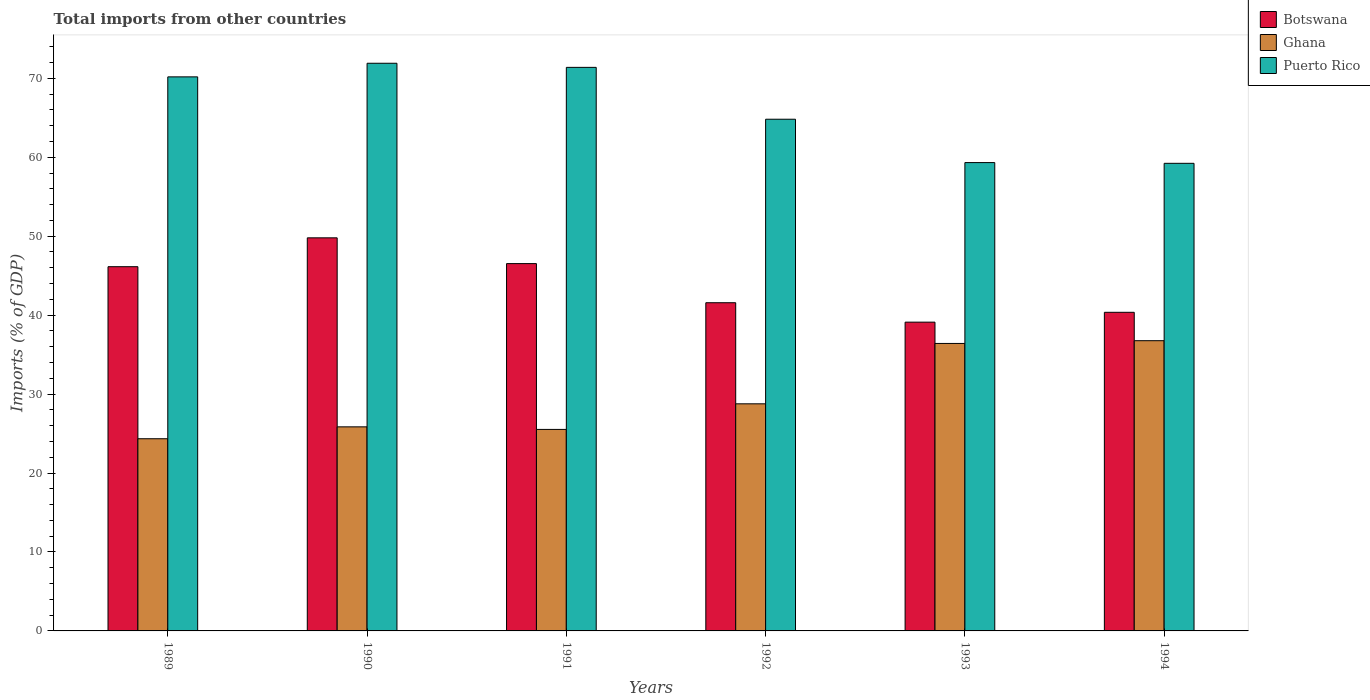How many different coloured bars are there?
Your response must be concise. 3. Are the number of bars on each tick of the X-axis equal?
Provide a succinct answer. Yes. How many bars are there on the 4th tick from the left?
Keep it short and to the point. 3. How many bars are there on the 5th tick from the right?
Your answer should be compact. 3. What is the label of the 5th group of bars from the left?
Give a very brief answer. 1993. In how many cases, is the number of bars for a given year not equal to the number of legend labels?
Keep it short and to the point. 0. What is the total imports in Ghana in 1989?
Keep it short and to the point. 24.34. Across all years, what is the maximum total imports in Ghana?
Offer a very short reply. 36.76. Across all years, what is the minimum total imports in Ghana?
Keep it short and to the point. 24.34. In which year was the total imports in Puerto Rico minimum?
Your answer should be very brief. 1994. What is the total total imports in Botswana in the graph?
Keep it short and to the point. 263.5. What is the difference between the total imports in Botswana in 1992 and that in 1994?
Offer a very short reply. 1.21. What is the difference between the total imports in Puerto Rico in 1989 and the total imports in Ghana in 1994?
Provide a succinct answer. 33.42. What is the average total imports in Puerto Rico per year?
Your answer should be very brief. 66.14. In the year 1992, what is the difference between the total imports in Ghana and total imports in Puerto Rico?
Offer a very short reply. -36.05. What is the ratio of the total imports in Ghana in 1991 to that in 1993?
Your answer should be very brief. 0.7. Is the difference between the total imports in Ghana in 1990 and 1992 greater than the difference between the total imports in Puerto Rico in 1990 and 1992?
Offer a very short reply. No. What is the difference between the highest and the second highest total imports in Botswana?
Give a very brief answer. 3.26. What is the difference between the highest and the lowest total imports in Botswana?
Make the answer very short. 10.68. What does the 3rd bar from the right in 1989 represents?
Offer a very short reply. Botswana. How many bars are there?
Provide a succinct answer. 18. Are all the bars in the graph horizontal?
Ensure brevity in your answer.  No. How many years are there in the graph?
Offer a very short reply. 6. What is the difference between two consecutive major ticks on the Y-axis?
Your answer should be compact. 10. Are the values on the major ticks of Y-axis written in scientific E-notation?
Ensure brevity in your answer.  No. How many legend labels are there?
Offer a terse response. 3. How are the legend labels stacked?
Make the answer very short. Vertical. What is the title of the graph?
Your answer should be compact. Total imports from other countries. Does "Honduras" appear as one of the legend labels in the graph?
Provide a succinct answer. No. What is the label or title of the X-axis?
Make the answer very short. Years. What is the label or title of the Y-axis?
Give a very brief answer. Imports (% of GDP). What is the Imports (% of GDP) of Botswana in 1989?
Ensure brevity in your answer.  46.14. What is the Imports (% of GDP) of Ghana in 1989?
Make the answer very short. 24.34. What is the Imports (% of GDP) of Puerto Rico in 1989?
Provide a succinct answer. 70.18. What is the Imports (% of GDP) in Botswana in 1990?
Offer a terse response. 49.79. What is the Imports (% of GDP) of Ghana in 1990?
Provide a succinct answer. 25.85. What is the Imports (% of GDP) in Puerto Rico in 1990?
Your response must be concise. 71.91. What is the Imports (% of GDP) in Botswana in 1991?
Your answer should be very brief. 46.53. What is the Imports (% of GDP) of Ghana in 1991?
Give a very brief answer. 25.52. What is the Imports (% of GDP) in Puerto Rico in 1991?
Provide a short and direct response. 71.38. What is the Imports (% of GDP) in Botswana in 1992?
Offer a very short reply. 41.57. What is the Imports (% of GDP) of Ghana in 1992?
Offer a terse response. 28.77. What is the Imports (% of GDP) in Puerto Rico in 1992?
Offer a very short reply. 64.82. What is the Imports (% of GDP) in Botswana in 1993?
Give a very brief answer. 39.11. What is the Imports (% of GDP) of Ghana in 1993?
Your answer should be very brief. 36.42. What is the Imports (% of GDP) in Puerto Rico in 1993?
Offer a terse response. 59.32. What is the Imports (% of GDP) of Botswana in 1994?
Offer a very short reply. 40.36. What is the Imports (% of GDP) in Ghana in 1994?
Your answer should be very brief. 36.76. What is the Imports (% of GDP) of Puerto Rico in 1994?
Ensure brevity in your answer.  59.23. Across all years, what is the maximum Imports (% of GDP) in Botswana?
Offer a very short reply. 49.79. Across all years, what is the maximum Imports (% of GDP) of Ghana?
Keep it short and to the point. 36.76. Across all years, what is the maximum Imports (% of GDP) of Puerto Rico?
Keep it short and to the point. 71.91. Across all years, what is the minimum Imports (% of GDP) of Botswana?
Provide a succinct answer. 39.11. Across all years, what is the minimum Imports (% of GDP) in Ghana?
Provide a short and direct response. 24.34. Across all years, what is the minimum Imports (% of GDP) in Puerto Rico?
Your answer should be compact. 59.23. What is the total Imports (% of GDP) in Botswana in the graph?
Offer a terse response. 263.5. What is the total Imports (% of GDP) in Ghana in the graph?
Give a very brief answer. 177.66. What is the total Imports (% of GDP) in Puerto Rico in the graph?
Your answer should be compact. 396.84. What is the difference between the Imports (% of GDP) of Botswana in 1989 and that in 1990?
Provide a short and direct response. -3.66. What is the difference between the Imports (% of GDP) in Ghana in 1989 and that in 1990?
Offer a very short reply. -1.51. What is the difference between the Imports (% of GDP) of Puerto Rico in 1989 and that in 1990?
Provide a short and direct response. -1.72. What is the difference between the Imports (% of GDP) of Botswana in 1989 and that in 1991?
Your answer should be very brief. -0.39. What is the difference between the Imports (% of GDP) of Ghana in 1989 and that in 1991?
Offer a terse response. -1.18. What is the difference between the Imports (% of GDP) in Puerto Rico in 1989 and that in 1991?
Provide a short and direct response. -1.2. What is the difference between the Imports (% of GDP) in Botswana in 1989 and that in 1992?
Your answer should be very brief. 4.56. What is the difference between the Imports (% of GDP) in Ghana in 1989 and that in 1992?
Provide a succinct answer. -4.42. What is the difference between the Imports (% of GDP) in Puerto Rico in 1989 and that in 1992?
Give a very brief answer. 5.37. What is the difference between the Imports (% of GDP) of Botswana in 1989 and that in 1993?
Give a very brief answer. 7.02. What is the difference between the Imports (% of GDP) of Ghana in 1989 and that in 1993?
Ensure brevity in your answer.  -12.07. What is the difference between the Imports (% of GDP) of Puerto Rico in 1989 and that in 1993?
Your answer should be compact. 10.86. What is the difference between the Imports (% of GDP) in Botswana in 1989 and that in 1994?
Offer a terse response. 5.78. What is the difference between the Imports (% of GDP) of Ghana in 1989 and that in 1994?
Your answer should be compact. -12.42. What is the difference between the Imports (% of GDP) of Puerto Rico in 1989 and that in 1994?
Keep it short and to the point. 10.95. What is the difference between the Imports (% of GDP) of Botswana in 1990 and that in 1991?
Make the answer very short. 3.26. What is the difference between the Imports (% of GDP) in Ghana in 1990 and that in 1991?
Provide a short and direct response. 0.33. What is the difference between the Imports (% of GDP) of Puerto Rico in 1990 and that in 1991?
Make the answer very short. 0.52. What is the difference between the Imports (% of GDP) in Botswana in 1990 and that in 1992?
Offer a very short reply. 8.22. What is the difference between the Imports (% of GDP) in Ghana in 1990 and that in 1992?
Your answer should be very brief. -2.92. What is the difference between the Imports (% of GDP) in Puerto Rico in 1990 and that in 1992?
Offer a terse response. 7.09. What is the difference between the Imports (% of GDP) of Botswana in 1990 and that in 1993?
Provide a short and direct response. 10.68. What is the difference between the Imports (% of GDP) of Ghana in 1990 and that in 1993?
Ensure brevity in your answer.  -10.56. What is the difference between the Imports (% of GDP) in Puerto Rico in 1990 and that in 1993?
Offer a terse response. 12.58. What is the difference between the Imports (% of GDP) of Botswana in 1990 and that in 1994?
Offer a terse response. 9.43. What is the difference between the Imports (% of GDP) of Ghana in 1990 and that in 1994?
Your answer should be compact. -10.91. What is the difference between the Imports (% of GDP) of Puerto Rico in 1990 and that in 1994?
Keep it short and to the point. 12.68. What is the difference between the Imports (% of GDP) in Botswana in 1991 and that in 1992?
Ensure brevity in your answer.  4.96. What is the difference between the Imports (% of GDP) in Ghana in 1991 and that in 1992?
Your response must be concise. -3.24. What is the difference between the Imports (% of GDP) in Puerto Rico in 1991 and that in 1992?
Provide a succinct answer. 6.57. What is the difference between the Imports (% of GDP) in Botswana in 1991 and that in 1993?
Keep it short and to the point. 7.42. What is the difference between the Imports (% of GDP) of Ghana in 1991 and that in 1993?
Provide a succinct answer. -10.89. What is the difference between the Imports (% of GDP) of Puerto Rico in 1991 and that in 1993?
Ensure brevity in your answer.  12.06. What is the difference between the Imports (% of GDP) in Botswana in 1991 and that in 1994?
Your answer should be very brief. 6.17. What is the difference between the Imports (% of GDP) of Ghana in 1991 and that in 1994?
Make the answer very short. -11.24. What is the difference between the Imports (% of GDP) of Puerto Rico in 1991 and that in 1994?
Your answer should be compact. 12.15. What is the difference between the Imports (% of GDP) in Botswana in 1992 and that in 1993?
Make the answer very short. 2.46. What is the difference between the Imports (% of GDP) of Ghana in 1992 and that in 1993?
Make the answer very short. -7.65. What is the difference between the Imports (% of GDP) in Puerto Rico in 1992 and that in 1993?
Give a very brief answer. 5.49. What is the difference between the Imports (% of GDP) of Botswana in 1992 and that in 1994?
Keep it short and to the point. 1.21. What is the difference between the Imports (% of GDP) of Ghana in 1992 and that in 1994?
Keep it short and to the point. -7.99. What is the difference between the Imports (% of GDP) in Puerto Rico in 1992 and that in 1994?
Your answer should be compact. 5.59. What is the difference between the Imports (% of GDP) in Botswana in 1993 and that in 1994?
Give a very brief answer. -1.25. What is the difference between the Imports (% of GDP) in Ghana in 1993 and that in 1994?
Ensure brevity in your answer.  -0.35. What is the difference between the Imports (% of GDP) of Puerto Rico in 1993 and that in 1994?
Give a very brief answer. 0.09. What is the difference between the Imports (% of GDP) in Botswana in 1989 and the Imports (% of GDP) in Ghana in 1990?
Offer a very short reply. 20.29. What is the difference between the Imports (% of GDP) of Botswana in 1989 and the Imports (% of GDP) of Puerto Rico in 1990?
Give a very brief answer. -25.77. What is the difference between the Imports (% of GDP) of Ghana in 1989 and the Imports (% of GDP) of Puerto Rico in 1990?
Give a very brief answer. -47.56. What is the difference between the Imports (% of GDP) of Botswana in 1989 and the Imports (% of GDP) of Ghana in 1991?
Offer a very short reply. 20.61. What is the difference between the Imports (% of GDP) in Botswana in 1989 and the Imports (% of GDP) in Puerto Rico in 1991?
Ensure brevity in your answer.  -25.25. What is the difference between the Imports (% of GDP) of Ghana in 1989 and the Imports (% of GDP) of Puerto Rico in 1991?
Offer a very short reply. -47.04. What is the difference between the Imports (% of GDP) of Botswana in 1989 and the Imports (% of GDP) of Ghana in 1992?
Ensure brevity in your answer.  17.37. What is the difference between the Imports (% of GDP) of Botswana in 1989 and the Imports (% of GDP) of Puerto Rico in 1992?
Provide a succinct answer. -18.68. What is the difference between the Imports (% of GDP) of Ghana in 1989 and the Imports (% of GDP) of Puerto Rico in 1992?
Ensure brevity in your answer.  -40.47. What is the difference between the Imports (% of GDP) of Botswana in 1989 and the Imports (% of GDP) of Ghana in 1993?
Ensure brevity in your answer.  9.72. What is the difference between the Imports (% of GDP) in Botswana in 1989 and the Imports (% of GDP) in Puerto Rico in 1993?
Provide a short and direct response. -13.19. What is the difference between the Imports (% of GDP) of Ghana in 1989 and the Imports (% of GDP) of Puerto Rico in 1993?
Your response must be concise. -34.98. What is the difference between the Imports (% of GDP) in Botswana in 1989 and the Imports (% of GDP) in Ghana in 1994?
Your answer should be very brief. 9.37. What is the difference between the Imports (% of GDP) of Botswana in 1989 and the Imports (% of GDP) of Puerto Rico in 1994?
Your answer should be compact. -13.09. What is the difference between the Imports (% of GDP) in Ghana in 1989 and the Imports (% of GDP) in Puerto Rico in 1994?
Your answer should be compact. -34.89. What is the difference between the Imports (% of GDP) in Botswana in 1990 and the Imports (% of GDP) in Ghana in 1991?
Offer a very short reply. 24.27. What is the difference between the Imports (% of GDP) of Botswana in 1990 and the Imports (% of GDP) of Puerto Rico in 1991?
Make the answer very short. -21.59. What is the difference between the Imports (% of GDP) of Ghana in 1990 and the Imports (% of GDP) of Puerto Rico in 1991?
Keep it short and to the point. -45.53. What is the difference between the Imports (% of GDP) of Botswana in 1990 and the Imports (% of GDP) of Ghana in 1992?
Provide a succinct answer. 21.02. What is the difference between the Imports (% of GDP) of Botswana in 1990 and the Imports (% of GDP) of Puerto Rico in 1992?
Keep it short and to the point. -15.02. What is the difference between the Imports (% of GDP) in Ghana in 1990 and the Imports (% of GDP) in Puerto Rico in 1992?
Offer a very short reply. -38.97. What is the difference between the Imports (% of GDP) in Botswana in 1990 and the Imports (% of GDP) in Ghana in 1993?
Offer a very short reply. 13.38. What is the difference between the Imports (% of GDP) in Botswana in 1990 and the Imports (% of GDP) in Puerto Rico in 1993?
Ensure brevity in your answer.  -9.53. What is the difference between the Imports (% of GDP) in Ghana in 1990 and the Imports (% of GDP) in Puerto Rico in 1993?
Ensure brevity in your answer.  -33.47. What is the difference between the Imports (% of GDP) in Botswana in 1990 and the Imports (% of GDP) in Ghana in 1994?
Give a very brief answer. 13.03. What is the difference between the Imports (% of GDP) of Botswana in 1990 and the Imports (% of GDP) of Puerto Rico in 1994?
Give a very brief answer. -9.44. What is the difference between the Imports (% of GDP) of Ghana in 1990 and the Imports (% of GDP) of Puerto Rico in 1994?
Your answer should be very brief. -33.38. What is the difference between the Imports (% of GDP) of Botswana in 1991 and the Imports (% of GDP) of Ghana in 1992?
Your answer should be very brief. 17.76. What is the difference between the Imports (% of GDP) of Botswana in 1991 and the Imports (% of GDP) of Puerto Rico in 1992?
Your answer should be compact. -18.29. What is the difference between the Imports (% of GDP) in Ghana in 1991 and the Imports (% of GDP) in Puerto Rico in 1992?
Offer a terse response. -39.29. What is the difference between the Imports (% of GDP) of Botswana in 1991 and the Imports (% of GDP) of Ghana in 1993?
Your answer should be compact. 10.11. What is the difference between the Imports (% of GDP) in Botswana in 1991 and the Imports (% of GDP) in Puerto Rico in 1993?
Your response must be concise. -12.8. What is the difference between the Imports (% of GDP) of Ghana in 1991 and the Imports (% of GDP) of Puerto Rico in 1993?
Provide a short and direct response. -33.8. What is the difference between the Imports (% of GDP) in Botswana in 1991 and the Imports (% of GDP) in Ghana in 1994?
Provide a short and direct response. 9.77. What is the difference between the Imports (% of GDP) in Botswana in 1991 and the Imports (% of GDP) in Puerto Rico in 1994?
Your response must be concise. -12.7. What is the difference between the Imports (% of GDP) of Ghana in 1991 and the Imports (% of GDP) of Puerto Rico in 1994?
Your answer should be very brief. -33.71. What is the difference between the Imports (% of GDP) in Botswana in 1992 and the Imports (% of GDP) in Ghana in 1993?
Your answer should be very brief. 5.16. What is the difference between the Imports (% of GDP) of Botswana in 1992 and the Imports (% of GDP) of Puerto Rico in 1993?
Provide a succinct answer. -17.75. What is the difference between the Imports (% of GDP) in Ghana in 1992 and the Imports (% of GDP) in Puerto Rico in 1993?
Make the answer very short. -30.56. What is the difference between the Imports (% of GDP) in Botswana in 1992 and the Imports (% of GDP) in Ghana in 1994?
Offer a very short reply. 4.81. What is the difference between the Imports (% of GDP) of Botswana in 1992 and the Imports (% of GDP) of Puerto Rico in 1994?
Give a very brief answer. -17.66. What is the difference between the Imports (% of GDP) of Ghana in 1992 and the Imports (% of GDP) of Puerto Rico in 1994?
Provide a succinct answer. -30.46. What is the difference between the Imports (% of GDP) of Botswana in 1993 and the Imports (% of GDP) of Ghana in 1994?
Offer a very short reply. 2.35. What is the difference between the Imports (% of GDP) in Botswana in 1993 and the Imports (% of GDP) in Puerto Rico in 1994?
Give a very brief answer. -20.12. What is the difference between the Imports (% of GDP) of Ghana in 1993 and the Imports (% of GDP) of Puerto Rico in 1994?
Give a very brief answer. -22.82. What is the average Imports (% of GDP) in Botswana per year?
Your response must be concise. 43.92. What is the average Imports (% of GDP) in Ghana per year?
Give a very brief answer. 29.61. What is the average Imports (% of GDP) in Puerto Rico per year?
Your response must be concise. 66.14. In the year 1989, what is the difference between the Imports (% of GDP) in Botswana and Imports (% of GDP) in Ghana?
Offer a terse response. 21.79. In the year 1989, what is the difference between the Imports (% of GDP) of Botswana and Imports (% of GDP) of Puerto Rico?
Your response must be concise. -24.05. In the year 1989, what is the difference between the Imports (% of GDP) of Ghana and Imports (% of GDP) of Puerto Rico?
Offer a very short reply. -45.84. In the year 1990, what is the difference between the Imports (% of GDP) in Botswana and Imports (% of GDP) in Ghana?
Ensure brevity in your answer.  23.94. In the year 1990, what is the difference between the Imports (% of GDP) of Botswana and Imports (% of GDP) of Puerto Rico?
Offer a very short reply. -22.11. In the year 1990, what is the difference between the Imports (% of GDP) in Ghana and Imports (% of GDP) in Puerto Rico?
Ensure brevity in your answer.  -46.06. In the year 1991, what is the difference between the Imports (% of GDP) in Botswana and Imports (% of GDP) in Ghana?
Your answer should be compact. 21. In the year 1991, what is the difference between the Imports (% of GDP) in Botswana and Imports (% of GDP) in Puerto Rico?
Provide a short and direct response. -24.86. In the year 1991, what is the difference between the Imports (% of GDP) of Ghana and Imports (% of GDP) of Puerto Rico?
Give a very brief answer. -45.86. In the year 1992, what is the difference between the Imports (% of GDP) in Botswana and Imports (% of GDP) in Ghana?
Make the answer very short. 12.8. In the year 1992, what is the difference between the Imports (% of GDP) of Botswana and Imports (% of GDP) of Puerto Rico?
Make the answer very short. -23.24. In the year 1992, what is the difference between the Imports (% of GDP) in Ghana and Imports (% of GDP) in Puerto Rico?
Provide a succinct answer. -36.05. In the year 1993, what is the difference between the Imports (% of GDP) in Botswana and Imports (% of GDP) in Ghana?
Make the answer very short. 2.7. In the year 1993, what is the difference between the Imports (% of GDP) in Botswana and Imports (% of GDP) in Puerto Rico?
Your answer should be compact. -20.21. In the year 1993, what is the difference between the Imports (% of GDP) in Ghana and Imports (% of GDP) in Puerto Rico?
Your answer should be very brief. -22.91. In the year 1994, what is the difference between the Imports (% of GDP) of Botswana and Imports (% of GDP) of Ghana?
Your answer should be compact. 3.6. In the year 1994, what is the difference between the Imports (% of GDP) of Botswana and Imports (% of GDP) of Puerto Rico?
Provide a short and direct response. -18.87. In the year 1994, what is the difference between the Imports (% of GDP) in Ghana and Imports (% of GDP) in Puerto Rico?
Give a very brief answer. -22.47. What is the ratio of the Imports (% of GDP) of Botswana in 1989 to that in 1990?
Offer a terse response. 0.93. What is the ratio of the Imports (% of GDP) of Ghana in 1989 to that in 1990?
Your response must be concise. 0.94. What is the ratio of the Imports (% of GDP) in Puerto Rico in 1989 to that in 1990?
Provide a short and direct response. 0.98. What is the ratio of the Imports (% of GDP) in Botswana in 1989 to that in 1991?
Offer a very short reply. 0.99. What is the ratio of the Imports (% of GDP) of Ghana in 1989 to that in 1991?
Your answer should be very brief. 0.95. What is the ratio of the Imports (% of GDP) in Puerto Rico in 1989 to that in 1991?
Provide a short and direct response. 0.98. What is the ratio of the Imports (% of GDP) of Botswana in 1989 to that in 1992?
Give a very brief answer. 1.11. What is the ratio of the Imports (% of GDP) in Ghana in 1989 to that in 1992?
Offer a very short reply. 0.85. What is the ratio of the Imports (% of GDP) of Puerto Rico in 1989 to that in 1992?
Your answer should be very brief. 1.08. What is the ratio of the Imports (% of GDP) of Botswana in 1989 to that in 1993?
Your answer should be compact. 1.18. What is the ratio of the Imports (% of GDP) in Ghana in 1989 to that in 1993?
Ensure brevity in your answer.  0.67. What is the ratio of the Imports (% of GDP) of Puerto Rico in 1989 to that in 1993?
Provide a short and direct response. 1.18. What is the ratio of the Imports (% of GDP) of Botswana in 1989 to that in 1994?
Your answer should be compact. 1.14. What is the ratio of the Imports (% of GDP) in Ghana in 1989 to that in 1994?
Offer a terse response. 0.66. What is the ratio of the Imports (% of GDP) of Puerto Rico in 1989 to that in 1994?
Offer a terse response. 1.18. What is the ratio of the Imports (% of GDP) of Botswana in 1990 to that in 1991?
Offer a very short reply. 1.07. What is the ratio of the Imports (% of GDP) of Ghana in 1990 to that in 1991?
Offer a terse response. 1.01. What is the ratio of the Imports (% of GDP) in Puerto Rico in 1990 to that in 1991?
Offer a terse response. 1.01. What is the ratio of the Imports (% of GDP) of Botswana in 1990 to that in 1992?
Make the answer very short. 1.2. What is the ratio of the Imports (% of GDP) in Ghana in 1990 to that in 1992?
Keep it short and to the point. 0.9. What is the ratio of the Imports (% of GDP) in Puerto Rico in 1990 to that in 1992?
Provide a succinct answer. 1.11. What is the ratio of the Imports (% of GDP) in Botswana in 1990 to that in 1993?
Keep it short and to the point. 1.27. What is the ratio of the Imports (% of GDP) of Ghana in 1990 to that in 1993?
Ensure brevity in your answer.  0.71. What is the ratio of the Imports (% of GDP) of Puerto Rico in 1990 to that in 1993?
Offer a terse response. 1.21. What is the ratio of the Imports (% of GDP) of Botswana in 1990 to that in 1994?
Offer a very short reply. 1.23. What is the ratio of the Imports (% of GDP) in Ghana in 1990 to that in 1994?
Your answer should be compact. 0.7. What is the ratio of the Imports (% of GDP) of Puerto Rico in 1990 to that in 1994?
Provide a succinct answer. 1.21. What is the ratio of the Imports (% of GDP) in Botswana in 1991 to that in 1992?
Your answer should be compact. 1.12. What is the ratio of the Imports (% of GDP) in Ghana in 1991 to that in 1992?
Make the answer very short. 0.89. What is the ratio of the Imports (% of GDP) of Puerto Rico in 1991 to that in 1992?
Provide a succinct answer. 1.1. What is the ratio of the Imports (% of GDP) in Botswana in 1991 to that in 1993?
Ensure brevity in your answer.  1.19. What is the ratio of the Imports (% of GDP) of Ghana in 1991 to that in 1993?
Ensure brevity in your answer.  0.7. What is the ratio of the Imports (% of GDP) in Puerto Rico in 1991 to that in 1993?
Your answer should be compact. 1.2. What is the ratio of the Imports (% of GDP) in Botswana in 1991 to that in 1994?
Provide a succinct answer. 1.15. What is the ratio of the Imports (% of GDP) of Ghana in 1991 to that in 1994?
Ensure brevity in your answer.  0.69. What is the ratio of the Imports (% of GDP) in Puerto Rico in 1991 to that in 1994?
Your response must be concise. 1.21. What is the ratio of the Imports (% of GDP) of Botswana in 1992 to that in 1993?
Keep it short and to the point. 1.06. What is the ratio of the Imports (% of GDP) of Ghana in 1992 to that in 1993?
Provide a short and direct response. 0.79. What is the ratio of the Imports (% of GDP) in Puerto Rico in 1992 to that in 1993?
Your answer should be very brief. 1.09. What is the ratio of the Imports (% of GDP) in Botswana in 1992 to that in 1994?
Offer a terse response. 1.03. What is the ratio of the Imports (% of GDP) of Ghana in 1992 to that in 1994?
Offer a terse response. 0.78. What is the ratio of the Imports (% of GDP) of Puerto Rico in 1992 to that in 1994?
Provide a short and direct response. 1.09. What is the ratio of the Imports (% of GDP) of Botswana in 1993 to that in 1994?
Provide a succinct answer. 0.97. What is the ratio of the Imports (% of GDP) of Ghana in 1993 to that in 1994?
Provide a short and direct response. 0.99. What is the difference between the highest and the second highest Imports (% of GDP) in Botswana?
Offer a terse response. 3.26. What is the difference between the highest and the second highest Imports (% of GDP) of Ghana?
Keep it short and to the point. 0.35. What is the difference between the highest and the second highest Imports (% of GDP) of Puerto Rico?
Provide a succinct answer. 0.52. What is the difference between the highest and the lowest Imports (% of GDP) of Botswana?
Your response must be concise. 10.68. What is the difference between the highest and the lowest Imports (% of GDP) of Ghana?
Make the answer very short. 12.42. What is the difference between the highest and the lowest Imports (% of GDP) in Puerto Rico?
Make the answer very short. 12.68. 